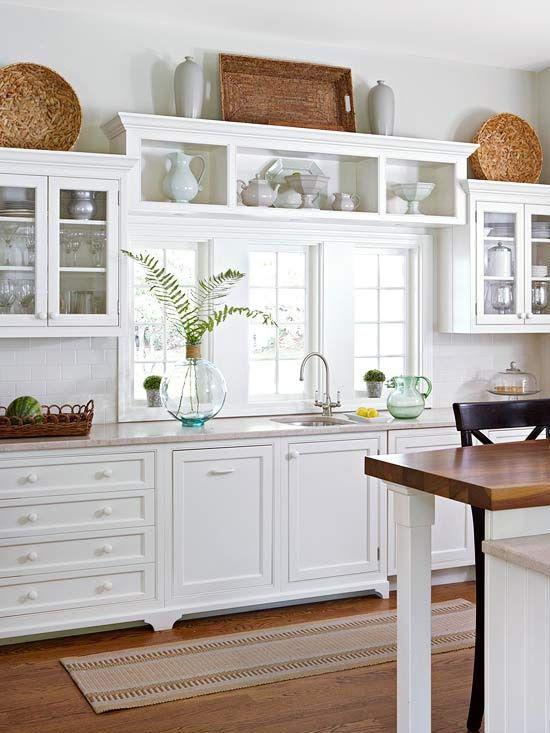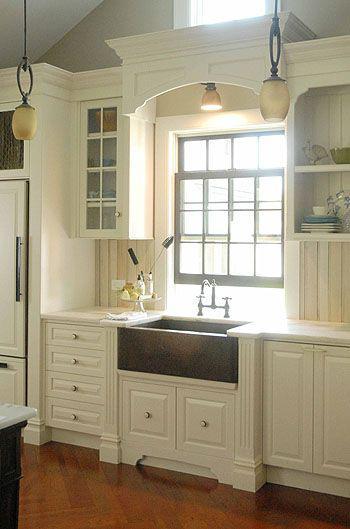The first image is the image on the left, the second image is the image on the right. Given the left and right images, does the statement "One kitchen has something decorative above and behind the sink, instead of a window to the outdoors." hold true? Answer yes or no. No. The first image is the image on the left, the second image is the image on the right. Evaluate the accuracy of this statement regarding the images: "A vase sits to the left of a sink with a window behind it.". Is it true? Answer yes or no. Yes. 